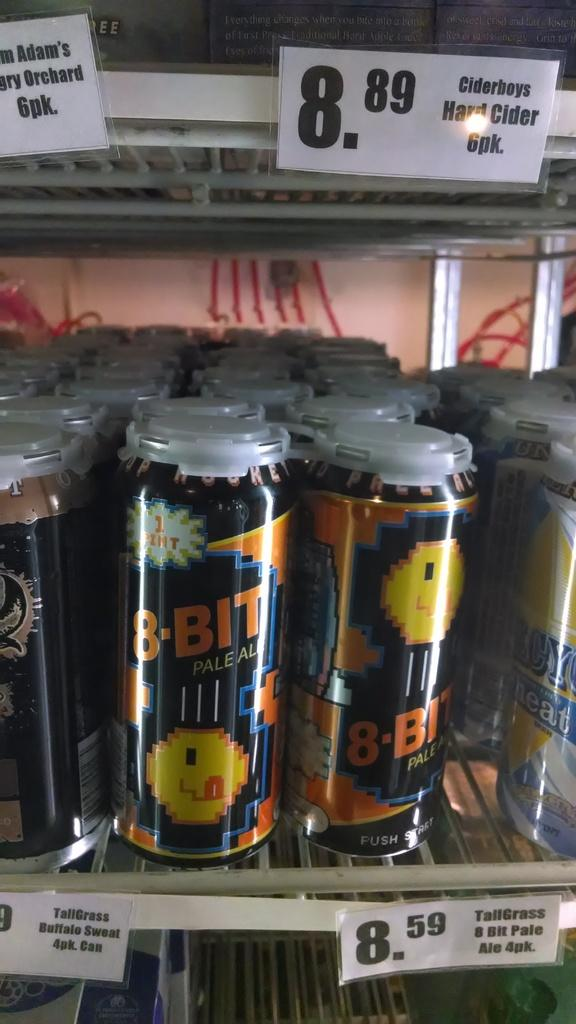<image>
Summarize the visual content of the image. Cans for 8 Bits ale is priced at 8.59. 